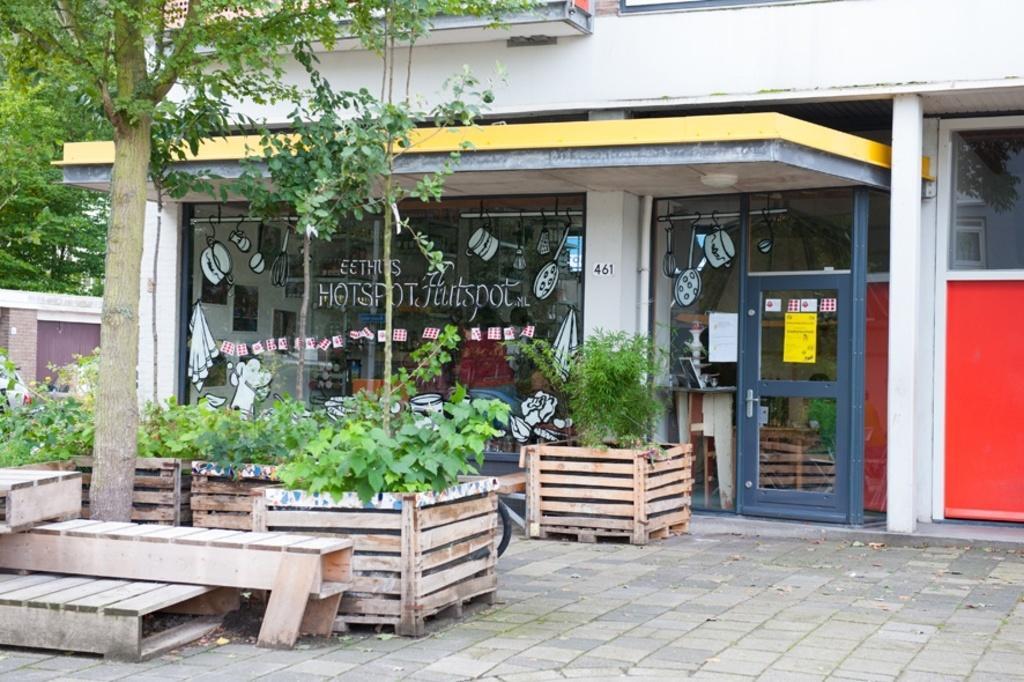Describe this image in one or two sentences. This picture is clicked outside. On the left we can see some wooden objects placed on the pavement and we can see the tree and some wooden objects containing plants. In the background we can see the building, text and some pictures on the glasses and we can see the doors and some other objects. In the background we can see the trees, a building and many other objects 